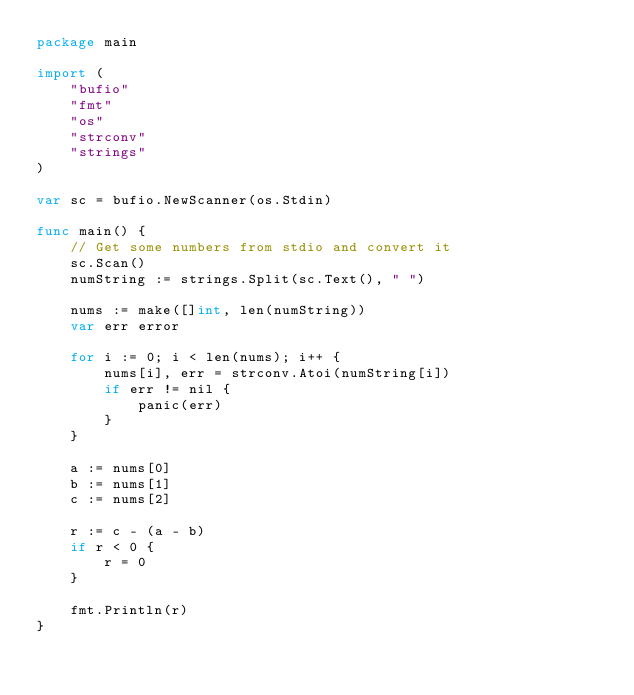Convert code to text. <code><loc_0><loc_0><loc_500><loc_500><_Go_>package main

import (
	"bufio"
	"fmt"
	"os"
	"strconv"
	"strings"
)

var sc = bufio.NewScanner(os.Stdin)

func main() {
	// Get some numbers from stdio and convert it
	sc.Scan()
	numString := strings.Split(sc.Text(), " ")

	nums := make([]int, len(numString))
	var err error

	for i := 0; i < len(nums); i++ {
		nums[i], err = strconv.Atoi(numString[i])
		if err != nil {
			panic(err)
		}
	}

	a := nums[0]
	b := nums[1]
	c := nums[2]

	r := c - (a - b)
	if r < 0 {
		r = 0
	}

	fmt.Println(r)
}</code> 